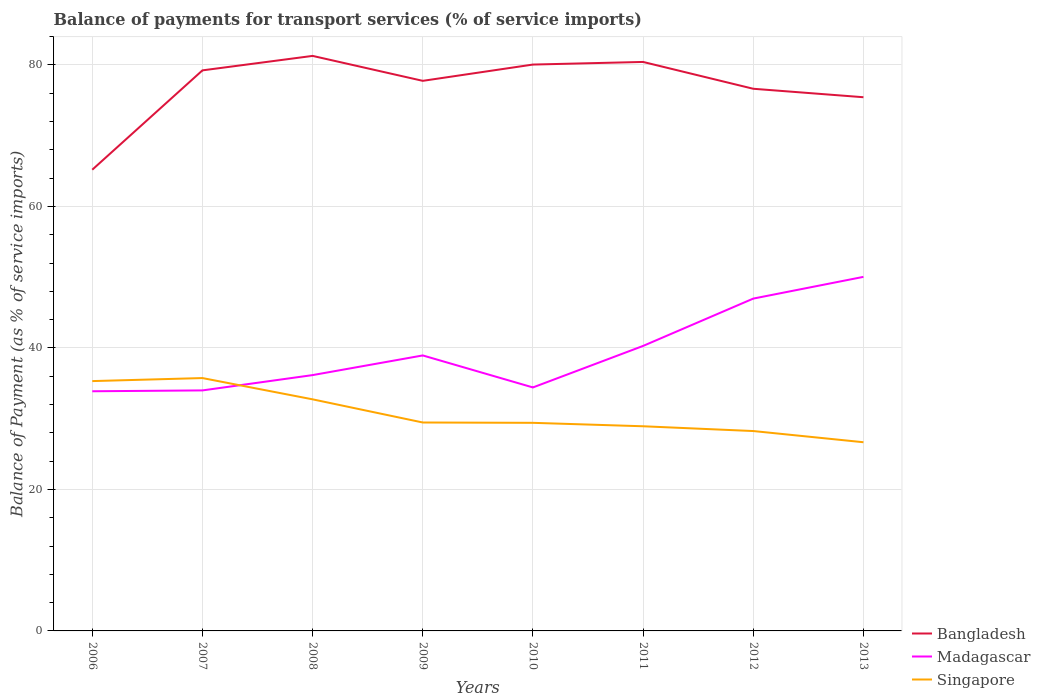How many different coloured lines are there?
Your response must be concise. 3. Across all years, what is the maximum balance of payments for transport services in Madagascar?
Your response must be concise. 33.88. What is the total balance of payments for transport services in Singapore in the graph?
Your answer should be very brief. 3.81. What is the difference between the highest and the second highest balance of payments for transport services in Singapore?
Provide a short and direct response. 9.07. What is the difference between the highest and the lowest balance of payments for transport services in Madagascar?
Your answer should be very brief. 3. How many lines are there?
Keep it short and to the point. 3. What is the difference between two consecutive major ticks on the Y-axis?
Provide a short and direct response. 20. How many legend labels are there?
Ensure brevity in your answer.  3. What is the title of the graph?
Provide a short and direct response. Balance of payments for transport services (% of service imports). Does "Slovak Republic" appear as one of the legend labels in the graph?
Offer a terse response. No. What is the label or title of the Y-axis?
Your answer should be very brief. Balance of Payment (as % of service imports). What is the Balance of Payment (as % of service imports) in Bangladesh in 2006?
Make the answer very short. 65.2. What is the Balance of Payment (as % of service imports) in Madagascar in 2006?
Your answer should be compact. 33.88. What is the Balance of Payment (as % of service imports) in Singapore in 2006?
Your answer should be very brief. 35.31. What is the Balance of Payment (as % of service imports) in Bangladesh in 2007?
Your response must be concise. 79.24. What is the Balance of Payment (as % of service imports) of Madagascar in 2007?
Your answer should be compact. 34. What is the Balance of Payment (as % of service imports) of Singapore in 2007?
Your response must be concise. 35.74. What is the Balance of Payment (as % of service imports) in Bangladesh in 2008?
Your response must be concise. 81.29. What is the Balance of Payment (as % of service imports) of Madagascar in 2008?
Offer a very short reply. 36.16. What is the Balance of Payment (as % of service imports) in Singapore in 2008?
Offer a terse response. 32.74. What is the Balance of Payment (as % of service imports) in Bangladesh in 2009?
Provide a short and direct response. 77.76. What is the Balance of Payment (as % of service imports) in Madagascar in 2009?
Ensure brevity in your answer.  38.94. What is the Balance of Payment (as % of service imports) of Singapore in 2009?
Ensure brevity in your answer.  29.46. What is the Balance of Payment (as % of service imports) of Bangladesh in 2010?
Provide a short and direct response. 80.06. What is the Balance of Payment (as % of service imports) of Madagascar in 2010?
Your answer should be compact. 34.42. What is the Balance of Payment (as % of service imports) of Singapore in 2010?
Your answer should be compact. 29.42. What is the Balance of Payment (as % of service imports) of Bangladesh in 2011?
Offer a very short reply. 80.43. What is the Balance of Payment (as % of service imports) of Madagascar in 2011?
Your answer should be very brief. 40.29. What is the Balance of Payment (as % of service imports) of Singapore in 2011?
Offer a very short reply. 28.93. What is the Balance of Payment (as % of service imports) in Bangladesh in 2012?
Make the answer very short. 76.64. What is the Balance of Payment (as % of service imports) in Madagascar in 2012?
Provide a succinct answer. 46.98. What is the Balance of Payment (as % of service imports) in Singapore in 2012?
Your answer should be very brief. 28.25. What is the Balance of Payment (as % of service imports) in Bangladesh in 2013?
Offer a terse response. 75.44. What is the Balance of Payment (as % of service imports) of Madagascar in 2013?
Make the answer very short. 50.05. What is the Balance of Payment (as % of service imports) in Singapore in 2013?
Offer a terse response. 26.67. Across all years, what is the maximum Balance of Payment (as % of service imports) of Bangladesh?
Ensure brevity in your answer.  81.29. Across all years, what is the maximum Balance of Payment (as % of service imports) in Madagascar?
Your answer should be very brief. 50.05. Across all years, what is the maximum Balance of Payment (as % of service imports) of Singapore?
Offer a very short reply. 35.74. Across all years, what is the minimum Balance of Payment (as % of service imports) of Bangladesh?
Keep it short and to the point. 65.2. Across all years, what is the minimum Balance of Payment (as % of service imports) of Madagascar?
Make the answer very short. 33.88. Across all years, what is the minimum Balance of Payment (as % of service imports) of Singapore?
Offer a terse response. 26.67. What is the total Balance of Payment (as % of service imports) of Bangladesh in the graph?
Offer a terse response. 616.05. What is the total Balance of Payment (as % of service imports) of Madagascar in the graph?
Your answer should be very brief. 314.71. What is the total Balance of Payment (as % of service imports) of Singapore in the graph?
Ensure brevity in your answer.  246.53. What is the difference between the Balance of Payment (as % of service imports) of Bangladesh in 2006 and that in 2007?
Give a very brief answer. -14.04. What is the difference between the Balance of Payment (as % of service imports) in Madagascar in 2006 and that in 2007?
Make the answer very short. -0.12. What is the difference between the Balance of Payment (as % of service imports) of Singapore in 2006 and that in 2007?
Keep it short and to the point. -0.43. What is the difference between the Balance of Payment (as % of service imports) in Bangladesh in 2006 and that in 2008?
Ensure brevity in your answer.  -16.09. What is the difference between the Balance of Payment (as % of service imports) of Madagascar in 2006 and that in 2008?
Provide a succinct answer. -2.28. What is the difference between the Balance of Payment (as % of service imports) in Singapore in 2006 and that in 2008?
Offer a terse response. 2.58. What is the difference between the Balance of Payment (as % of service imports) of Bangladesh in 2006 and that in 2009?
Ensure brevity in your answer.  -12.56. What is the difference between the Balance of Payment (as % of service imports) of Madagascar in 2006 and that in 2009?
Your answer should be very brief. -5.06. What is the difference between the Balance of Payment (as % of service imports) in Singapore in 2006 and that in 2009?
Your response must be concise. 5.85. What is the difference between the Balance of Payment (as % of service imports) in Bangladesh in 2006 and that in 2010?
Ensure brevity in your answer.  -14.86. What is the difference between the Balance of Payment (as % of service imports) in Madagascar in 2006 and that in 2010?
Ensure brevity in your answer.  -0.54. What is the difference between the Balance of Payment (as % of service imports) in Singapore in 2006 and that in 2010?
Ensure brevity in your answer.  5.9. What is the difference between the Balance of Payment (as % of service imports) in Bangladesh in 2006 and that in 2011?
Your answer should be compact. -15.23. What is the difference between the Balance of Payment (as % of service imports) of Madagascar in 2006 and that in 2011?
Provide a short and direct response. -6.41. What is the difference between the Balance of Payment (as % of service imports) of Singapore in 2006 and that in 2011?
Ensure brevity in your answer.  6.38. What is the difference between the Balance of Payment (as % of service imports) of Bangladesh in 2006 and that in 2012?
Your response must be concise. -11.44. What is the difference between the Balance of Payment (as % of service imports) of Madagascar in 2006 and that in 2012?
Give a very brief answer. -13.1. What is the difference between the Balance of Payment (as % of service imports) in Singapore in 2006 and that in 2012?
Ensure brevity in your answer.  7.06. What is the difference between the Balance of Payment (as % of service imports) of Bangladesh in 2006 and that in 2013?
Offer a very short reply. -10.25. What is the difference between the Balance of Payment (as % of service imports) in Madagascar in 2006 and that in 2013?
Offer a terse response. -16.17. What is the difference between the Balance of Payment (as % of service imports) in Singapore in 2006 and that in 2013?
Provide a succinct answer. 8.64. What is the difference between the Balance of Payment (as % of service imports) of Bangladesh in 2007 and that in 2008?
Give a very brief answer. -2.05. What is the difference between the Balance of Payment (as % of service imports) in Madagascar in 2007 and that in 2008?
Provide a succinct answer. -2.16. What is the difference between the Balance of Payment (as % of service imports) of Singapore in 2007 and that in 2008?
Provide a succinct answer. 3.01. What is the difference between the Balance of Payment (as % of service imports) in Bangladesh in 2007 and that in 2009?
Provide a succinct answer. 1.48. What is the difference between the Balance of Payment (as % of service imports) of Madagascar in 2007 and that in 2009?
Offer a terse response. -4.94. What is the difference between the Balance of Payment (as % of service imports) in Singapore in 2007 and that in 2009?
Provide a succinct answer. 6.28. What is the difference between the Balance of Payment (as % of service imports) of Bangladesh in 2007 and that in 2010?
Give a very brief answer. -0.82. What is the difference between the Balance of Payment (as % of service imports) of Madagascar in 2007 and that in 2010?
Ensure brevity in your answer.  -0.42. What is the difference between the Balance of Payment (as % of service imports) of Singapore in 2007 and that in 2010?
Offer a terse response. 6.33. What is the difference between the Balance of Payment (as % of service imports) of Bangladesh in 2007 and that in 2011?
Ensure brevity in your answer.  -1.19. What is the difference between the Balance of Payment (as % of service imports) in Madagascar in 2007 and that in 2011?
Your answer should be very brief. -6.29. What is the difference between the Balance of Payment (as % of service imports) of Singapore in 2007 and that in 2011?
Your response must be concise. 6.81. What is the difference between the Balance of Payment (as % of service imports) in Bangladesh in 2007 and that in 2012?
Ensure brevity in your answer.  2.6. What is the difference between the Balance of Payment (as % of service imports) in Madagascar in 2007 and that in 2012?
Make the answer very short. -12.98. What is the difference between the Balance of Payment (as % of service imports) of Singapore in 2007 and that in 2012?
Provide a succinct answer. 7.49. What is the difference between the Balance of Payment (as % of service imports) in Bangladesh in 2007 and that in 2013?
Ensure brevity in your answer.  3.8. What is the difference between the Balance of Payment (as % of service imports) in Madagascar in 2007 and that in 2013?
Ensure brevity in your answer.  -16.05. What is the difference between the Balance of Payment (as % of service imports) of Singapore in 2007 and that in 2013?
Your response must be concise. 9.07. What is the difference between the Balance of Payment (as % of service imports) in Bangladesh in 2008 and that in 2009?
Your answer should be very brief. 3.53. What is the difference between the Balance of Payment (as % of service imports) of Madagascar in 2008 and that in 2009?
Offer a terse response. -2.78. What is the difference between the Balance of Payment (as % of service imports) in Singapore in 2008 and that in 2009?
Give a very brief answer. 3.27. What is the difference between the Balance of Payment (as % of service imports) of Bangladesh in 2008 and that in 2010?
Offer a terse response. 1.22. What is the difference between the Balance of Payment (as % of service imports) in Madagascar in 2008 and that in 2010?
Give a very brief answer. 1.74. What is the difference between the Balance of Payment (as % of service imports) in Singapore in 2008 and that in 2010?
Keep it short and to the point. 3.32. What is the difference between the Balance of Payment (as % of service imports) in Bangladesh in 2008 and that in 2011?
Provide a succinct answer. 0.86. What is the difference between the Balance of Payment (as % of service imports) in Madagascar in 2008 and that in 2011?
Make the answer very short. -4.12. What is the difference between the Balance of Payment (as % of service imports) of Singapore in 2008 and that in 2011?
Your answer should be very brief. 3.81. What is the difference between the Balance of Payment (as % of service imports) in Bangladesh in 2008 and that in 2012?
Make the answer very short. 4.65. What is the difference between the Balance of Payment (as % of service imports) of Madagascar in 2008 and that in 2012?
Offer a terse response. -10.81. What is the difference between the Balance of Payment (as % of service imports) in Singapore in 2008 and that in 2012?
Provide a short and direct response. 4.48. What is the difference between the Balance of Payment (as % of service imports) of Bangladesh in 2008 and that in 2013?
Ensure brevity in your answer.  5.84. What is the difference between the Balance of Payment (as % of service imports) of Madagascar in 2008 and that in 2013?
Provide a succinct answer. -13.89. What is the difference between the Balance of Payment (as % of service imports) of Singapore in 2008 and that in 2013?
Provide a short and direct response. 6.06. What is the difference between the Balance of Payment (as % of service imports) in Bangladesh in 2009 and that in 2010?
Keep it short and to the point. -2.3. What is the difference between the Balance of Payment (as % of service imports) of Madagascar in 2009 and that in 2010?
Offer a terse response. 4.52. What is the difference between the Balance of Payment (as % of service imports) of Singapore in 2009 and that in 2010?
Offer a terse response. 0.05. What is the difference between the Balance of Payment (as % of service imports) of Bangladesh in 2009 and that in 2011?
Provide a succinct answer. -2.67. What is the difference between the Balance of Payment (as % of service imports) in Madagascar in 2009 and that in 2011?
Ensure brevity in your answer.  -1.35. What is the difference between the Balance of Payment (as % of service imports) of Singapore in 2009 and that in 2011?
Make the answer very short. 0.53. What is the difference between the Balance of Payment (as % of service imports) of Bangladesh in 2009 and that in 2012?
Your response must be concise. 1.12. What is the difference between the Balance of Payment (as % of service imports) in Madagascar in 2009 and that in 2012?
Give a very brief answer. -8.03. What is the difference between the Balance of Payment (as % of service imports) of Singapore in 2009 and that in 2012?
Make the answer very short. 1.21. What is the difference between the Balance of Payment (as % of service imports) of Bangladesh in 2009 and that in 2013?
Offer a terse response. 2.32. What is the difference between the Balance of Payment (as % of service imports) of Madagascar in 2009 and that in 2013?
Make the answer very short. -11.11. What is the difference between the Balance of Payment (as % of service imports) of Singapore in 2009 and that in 2013?
Your response must be concise. 2.79. What is the difference between the Balance of Payment (as % of service imports) in Bangladesh in 2010 and that in 2011?
Provide a succinct answer. -0.37. What is the difference between the Balance of Payment (as % of service imports) of Madagascar in 2010 and that in 2011?
Provide a short and direct response. -5.87. What is the difference between the Balance of Payment (as % of service imports) of Singapore in 2010 and that in 2011?
Provide a succinct answer. 0.49. What is the difference between the Balance of Payment (as % of service imports) in Bangladesh in 2010 and that in 2012?
Offer a terse response. 3.42. What is the difference between the Balance of Payment (as % of service imports) of Madagascar in 2010 and that in 2012?
Offer a very short reply. -12.56. What is the difference between the Balance of Payment (as % of service imports) of Singapore in 2010 and that in 2012?
Ensure brevity in your answer.  1.16. What is the difference between the Balance of Payment (as % of service imports) in Bangladesh in 2010 and that in 2013?
Give a very brief answer. 4.62. What is the difference between the Balance of Payment (as % of service imports) in Madagascar in 2010 and that in 2013?
Your answer should be compact. -15.63. What is the difference between the Balance of Payment (as % of service imports) of Singapore in 2010 and that in 2013?
Give a very brief answer. 2.74. What is the difference between the Balance of Payment (as % of service imports) in Bangladesh in 2011 and that in 2012?
Provide a short and direct response. 3.79. What is the difference between the Balance of Payment (as % of service imports) of Madagascar in 2011 and that in 2012?
Offer a very short reply. -6.69. What is the difference between the Balance of Payment (as % of service imports) in Singapore in 2011 and that in 2012?
Your answer should be very brief. 0.67. What is the difference between the Balance of Payment (as % of service imports) in Bangladesh in 2011 and that in 2013?
Offer a very short reply. 4.99. What is the difference between the Balance of Payment (as % of service imports) in Madagascar in 2011 and that in 2013?
Your answer should be compact. -9.76. What is the difference between the Balance of Payment (as % of service imports) in Singapore in 2011 and that in 2013?
Provide a succinct answer. 2.26. What is the difference between the Balance of Payment (as % of service imports) of Bangladesh in 2012 and that in 2013?
Keep it short and to the point. 1.2. What is the difference between the Balance of Payment (as % of service imports) in Madagascar in 2012 and that in 2013?
Ensure brevity in your answer.  -3.07. What is the difference between the Balance of Payment (as % of service imports) of Singapore in 2012 and that in 2013?
Your response must be concise. 1.58. What is the difference between the Balance of Payment (as % of service imports) in Bangladesh in 2006 and the Balance of Payment (as % of service imports) in Madagascar in 2007?
Offer a very short reply. 31.2. What is the difference between the Balance of Payment (as % of service imports) of Bangladesh in 2006 and the Balance of Payment (as % of service imports) of Singapore in 2007?
Your response must be concise. 29.45. What is the difference between the Balance of Payment (as % of service imports) of Madagascar in 2006 and the Balance of Payment (as % of service imports) of Singapore in 2007?
Your response must be concise. -1.87. What is the difference between the Balance of Payment (as % of service imports) in Bangladesh in 2006 and the Balance of Payment (as % of service imports) in Madagascar in 2008?
Your answer should be very brief. 29.03. What is the difference between the Balance of Payment (as % of service imports) in Bangladesh in 2006 and the Balance of Payment (as % of service imports) in Singapore in 2008?
Provide a short and direct response. 32.46. What is the difference between the Balance of Payment (as % of service imports) of Madagascar in 2006 and the Balance of Payment (as % of service imports) of Singapore in 2008?
Offer a terse response. 1.14. What is the difference between the Balance of Payment (as % of service imports) of Bangladesh in 2006 and the Balance of Payment (as % of service imports) of Madagascar in 2009?
Your answer should be compact. 26.25. What is the difference between the Balance of Payment (as % of service imports) in Bangladesh in 2006 and the Balance of Payment (as % of service imports) in Singapore in 2009?
Offer a terse response. 35.73. What is the difference between the Balance of Payment (as % of service imports) of Madagascar in 2006 and the Balance of Payment (as % of service imports) of Singapore in 2009?
Your answer should be very brief. 4.42. What is the difference between the Balance of Payment (as % of service imports) in Bangladesh in 2006 and the Balance of Payment (as % of service imports) in Madagascar in 2010?
Offer a very short reply. 30.78. What is the difference between the Balance of Payment (as % of service imports) in Bangladesh in 2006 and the Balance of Payment (as % of service imports) in Singapore in 2010?
Offer a terse response. 35.78. What is the difference between the Balance of Payment (as % of service imports) of Madagascar in 2006 and the Balance of Payment (as % of service imports) of Singapore in 2010?
Provide a succinct answer. 4.46. What is the difference between the Balance of Payment (as % of service imports) in Bangladesh in 2006 and the Balance of Payment (as % of service imports) in Madagascar in 2011?
Your answer should be very brief. 24.91. What is the difference between the Balance of Payment (as % of service imports) of Bangladesh in 2006 and the Balance of Payment (as % of service imports) of Singapore in 2011?
Make the answer very short. 36.27. What is the difference between the Balance of Payment (as % of service imports) in Madagascar in 2006 and the Balance of Payment (as % of service imports) in Singapore in 2011?
Ensure brevity in your answer.  4.95. What is the difference between the Balance of Payment (as % of service imports) of Bangladesh in 2006 and the Balance of Payment (as % of service imports) of Madagascar in 2012?
Your answer should be compact. 18.22. What is the difference between the Balance of Payment (as % of service imports) in Bangladesh in 2006 and the Balance of Payment (as % of service imports) in Singapore in 2012?
Your answer should be compact. 36.94. What is the difference between the Balance of Payment (as % of service imports) of Madagascar in 2006 and the Balance of Payment (as % of service imports) of Singapore in 2012?
Ensure brevity in your answer.  5.62. What is the difference between the Balance of Payment (as % of service imports) of Bangladesh in 2006 and the Balance of Payment (as % of service imports) of Madagascar in 2013?
Your response must be concise. 15.15. What is the difference between the Balance of Payment (as % of service imports) of Bangladesh in 2006 and the Balance of Payment (as % of service imports) of Singapore in 2013?
Give a very brief answer. 38.52. What is the difference between the Balance of Payment (as % of service imports) in Madagascar in 2006 and the Balance of Payment (as % of service imports) in Singapore in 2013?
Ensure brevity in your answer.  7.21. What is the difference between the Balance of Payment (as % of service imports) in Bangladesh in 2007 and the Balance of Payment (as % of service imports) in Madagascar in 2008?
Offer a very short reply. 43.08. What is the difference between the Balance of Payment (as % of service imports) in Bangladesh in 2007 and the Balance of Payment (as % of service imports) in Singapore in 2008?
Provide a short and direct response. 46.5. What is the difference between the Balance of Payment (as % of service imports) of Madagascar in 2007 and the Balance of Payment (as % of service imports) of Singapore in 2008?
Ensure brevity in your answer.  1.26. What is the difference between the Balance of Payment (as % of service imports) of Bangladesh in 2007 and the Balance of Payment (as % of service imports) of Madagascar in 2009?
Offer a terse response. 40.3. What is the difference between the Balance of Payment (as % of service imports) of Bangladesh in 2007 and the Balance of Payment (as % of service imports) of Singapore in 2009?
Keep it short and to the point. 49.78. What is the difference between the Balance of Payment (as % of service imports) in Madagascar in 2007 and the Balance of Payment (as % of service imports) in Singapore in 2009?
Ensure brevity in your answer.  4.54. What is the difference between the Balance of Payment (as % of service imports) in Bangladesh in 2007 and the Balance of Payment (as % of service imports) in Madagascar in 2010?
Your answer should be compact. 44.82. What is the difference between the Balance of Payment (as % of service imports) in Bangladesh in 2007 and the Balance of Payment (as % of service imports) in Singapore in 2010?
Make the answer very short. 49.82. What is the difference between the Balance of Payment (as % of service imports) of Madagascar in 2007 and the Balance of Payment (as % of service imports) of Singapore in 2010?
Your answer should be very brief. 4.58. What is the difference between the Balance of Payment (as % of service imports) of Bangladesh in 2007 and the Balance of Payment (as % of service imports) of Madagascar in 2011?
Give a very brief answer. 38.95. What is the difference between the Balance of Payment (as % of service imports) in Bangladesh in 2007 and the Balance of Payment (as % of service imports) in Singapore in 2011?
Make the answer very short. 50.31. What is the difference between the Balance of Payment (as % of service imports) of Madagascar in 2007 and the Balance of Payment (as % of service imports) of Singapore in 2011?
Your answer should be compact. 5.07. What is the difference between the Balance of Payment (as % of service imports) of Bangladesh in 2007 and the Balance of Payment (as % of service imports) of Madagascar in 2012?
Keep it short and to the point. 32.26. What is the difference between the Balance of Payment (as % of service imports) of Bangladesh in 2007 and the Balance of Payment (as % of service imports) of Singapore in 2012?
Your answer should be compact. 50.98. What is the difference between the Balance of Payment (as % of service imports) in Madagascar in 2007 and the Balance of Payment (as % of service imports) in Singapore in 2012?
Your answer should be compact. 5.74. What is the difference between the Balance of Payment (as % of service imports) of Bangladesh in 2007 and the Balance of Payment (as % of service imports) of Madagascar in 2013?
Keep it short and to the point. 29.19. What is the difference between the Balance of Payment (as % of service imports) of Bangladesh in 2007 and the Balance of Payment (as % of service imports) of Singapore in 2013?
Your answer should be very brief. 52.57. What is the difference between the Balance of Payment (as % of service imports) in Madagascar in 2007 and the Balance of Payment (as % of service imports) in Singapore in 2013?
Your answer should be very brief. 7.33. What is the difference between the Balance of Payment (as % of service imports) in Bangladesh in 2008 and the Balance of Payment (as % of service imports) in Madagascar in 2009?
Ensure brevity in your answer.  42.34. What is the difference between the Balance of Payment (as % of service imports) in Bangladesh in 2008 and the Balance of Payment (as % of service imports) in Singapore in 2009?
Offer a very short reply. 51.82. What is the difference between the Balance of Payment (as % of service imports) of Madagascar in 2008 and the Balance of Payment (as % of service imports) of Singapore in 2009?
Provide a short and direct response. 6.7. What is the difference between the Balance of Payment (as % of service imports) of Bangladesh in 2008 and the Balance of Payment (as % of service imports) of Madagascar in 2010?
Provide a short and direct response. 46.87. What is the difference between the Balance of Payment (as % of service imports) in Bangladesh in 2008 and the Balance of Payment (as % of service imports) in Singapore in 2010?
Offer a terse response. 51.87. What is the difference between the Balance of Payment (as % of service imports) in Madagascar in 2008 and the Balance of Payment (as % of service imports) in Singapore in 2010?
Provide a succinct answer. 6.75. What is the difference between the Balance of Payment (as % of service imports) in Bangladesh in 2008 and the Balance of Payment (as % of service imports) in Madagascar in 2011?
Keep it short and to the point. 41. What is the difference between the Balance of Payment (as % of service imports) of Bangladesh in 2008 and the Balance of Payment (as % of service imports) of Singapore in 2011?
Give a very brief answer. 52.36. What is the difference between the Balance of Payment (as % of service imports) in Madagascar in 2008 and the Balance of Payment (as % of service imports) in Singapore in 2011?
Offer a very short reply. 7.23. What is the difference between the Balance of Payment (as % of service imports) of Bangladesh in 2008 and the Balance of Payment (as % of service imports) of Madagascar in 2012?
Make the answer very short. 34.31. What is the difference between the Balance of Payment (as % of service imports) of Bangladesh in 2008 and the Balance of Payment (as % of service imports) of Singapore in 2012?
Your answer should be compact. 53.03. What is the difference between the Balance of Payment (as % of service imports) of Madagascar in 2008 and the Balance of Payment (as % of service imports) of Singapore in 2012?
Keep it short and to the point. 7.91. What is the difference between the Balance of Payment (as % of service imports) of Bangladesh in 2008 and the Balance of Payment (as % of service imports) of Madagascar in 2013?
Your response must be concise. 31.24. What is the difference between the Balance of Payment (as % of service imports) of Bangladesh in 2008 and the Balance of Payment (as % of service imports) of Singapore in 2013?
Your response must be concise. 54.61. What is the difference between the Balance of Payment (as % of service imports) of Madagascar in 2008 and the Balance of Payment (as % of service imports) of Singapore in 2013?
Your response must be concise. 9.49. What is the difference between the Balance of Payment (as % of service imports) in Bangladesh in 2009 and the Balance of Payment (as % of service imports) in Madagascar in 2010?
Offer a very short reply. 43.34. What is the difference between the Balance of Payment (as % of service imports) of Bangladesh in 2009 and the Balance of Payment (as % of service imports) of Singapore in 2010?
Ensure brevity in your answer.  48.34. What is the difference between the Balance of Payment (as % of service imports) in Madagascar in 2009 and the Balance of Payment (as % of service imports) in Singapore in 2010?
Give a very brief answer. 9.53. What is the difference between the Balance of Payment (as % of service imports) in Bangladesh in 2009 and the Balance of Payment (as % of service imports) in Madagascar in 2011?
Offer a very short reply. 37.47. What is the difference between the Balance of Payment (as % of service imports) of Bangladesh in 2009 and the Balance of Payment (as % of service imports) of Singapore in 2011?
Give a very brief answer. 48.83. What is the difference between the Balance of Payment (as % of service imports) of Madagascar in 2009 and the Balance of Payment (as % of service imports) of Singapore in 2011?
Provide a succinct answer. 10.01. What is the difference between the Balance of Payment (as % of service imports) in Bangladesh in 2009 and the Balance of Payment (as % of service imports) in Madagascar in 2012?
Make the answer very short. 30.78. What is the difference between the Balance of Payment (as % of service imports) of Bangladesh in 2009 and the Balance of Payment (as % of service imports) of Singapore in 2012?
Ensure brevity in your answer.  49.5. What is the difference between the Balance of Payment (as % of service imports) of Madagascar in 2009 and the Balance of Payment (as % of service imports) of Singapore in 2012?
Provide a short and direct response. 10.69. What is the difference between the Balance of Payment (as % of service imports) of Bangladesh in 2009 and the Balance of Payment (as % of service imports) of Madagascar in 2013?
Provide a succinct answer. 27.71. What is the difference between the Balance of Payment (as % of service imports) of Bangladesh in 2009 and the Balance of Payment (as % of service imports) of Singapore in 2013?
Your answer should be very brief. 51.09. What is the difference between the Balance of Payment (as % of service imports) in Madagascar in 2009 and the Balance of Payment (as % of service imports) in Singapore in 2013?
Offer a very short reply. 12.27. What is the difference between the Balance of Payment (as % of service imports) in Bangladesh in 2010 and the Balance of Payment (as % of service imports) in Madagascar in 2011?
Keep it short and to the point. 39.77. What is the difference between the Balance of Payment (as % of service imports) in Bangladesh in 2010 and the Balance of Payment (as % of service imports) in Singapore in 2011?
Offer a terse response. 51.13. What is the difference between the Balance of Payment (as % of service imports) in Madagascar in 2010 and the Balance of Payment (as % of service imports) in Singapore in 2011?
Make the answer very short. 5.49. What is the difference between the Balance of Payment (as % of service imports) of Bangladesh in 2010 and the Balance of Payment (as % of service imports) of Madagascar in 2012?
Make the answer very short. 33.08. What is the difference between the Balance of Payment (as % of service imports) in Bangladesh in 2010 and the Balance of Payment (as % of service imports) in Singapore in 2012?
Your answer should be compact. 51.81. What is the difference between the Balance of Payment (as % of service imports) in Madagascar in 2010 and the Balance of Payment (as % of service imports) in Singapore in 2012?
Your response must be concise. 6.16. What is the difference between the Balance of Payment (as % of service imports) of Bangladesh in 2010 and the Balance of Payment (as % of service imports) of Madagascar in 2013?
Give a very brief answer. 30.01. What is the difference between the Balance of Payment (as % of service imports) of Bangladesh in 2010 and the Balance of Payment (as % of service imports) of Singapore in 2013?
Offer a very short reply. 53.39. What is the difference between the Balance of Payment (as % of service imports) in Madagascar in 2010 and the Balance of Payment (as % of service imports) in Singapore in 2013?
Provide a succinct answer. 7.75. What is the difference between the Balance of Payment (as % of service imports) of Bangladesh in 2011 and the Balance of Payment (as % of service imports) of Madagascar in 2012?
Keep it short and to the point. 33.45. What is the difference between the Balance of Payment (as % of service imports) in Bangladesh in 2011 and the Balance of Payment (as % of service imports) in Singapore in 2012?
Your answer should be compact. 52.17. What is the difference between the Balance of Payment (as % of service imports) of Madagascar in 2011 and the Balance of Payment (as % of service imports) of Singapore in 2012?
Keep it short and to the point. 12.03. What is the difference between the Balance of Payment (as % of service imports) in Bangladesh in 2011 and the Balance of Payment (as % of service imports) in Madagascar in 2013?
Offer a terse response. 30.38. What is the difference between the Balance of Payment (as % of service imports) in Bangladesh in 2011 and the Balance of Payment (as % of service imports) in Singapore in 2013?
Your answer should be compact. 53.76. What is the difference between the Balance of Payment (as % of service imports) in Madagascar in 2011 and the Balance of Payment (as % of service imports) in Singapore in 2013?
Offer a very short reply. 13.61. What is the difference between the Balance of Payment (as % of service imports) of Bangladesh in 2012 and the Balance of Payment (as % of service imports) of Madagascar in 2013?
Keep it short and to the point. 26.59. What is the difference between the Balance of Payment (as % of service imports) of Bangladesh in 2012 and the Balance of Payment (as % of service imports) of Singapore in 2013?
Ensure brevity in your answer.  49.97. What is the difference between the Balance of Payment (as % of service imports) of Madagascar in 2012 and the Balance of Payment (as % of service imports) of Singapore in 2013?
Provide a succinct answer. 20.3. What is the average Balance of Payment (as % of service imports) of Bangladesh per year?
Give a very brief answer. 77.01. What is the average Balance of Payment (as % of service imports) of Madagascar per year?
Provide a short and direct response. 39.34. What is the average Balance of Payment (as % of service imports) of Singapore per year?
Ensure brevity in your answer.  30.82. In the year 2006, what is the difference between the Balance of Payment (as % of service imports) in Bangladesh and Balance of Payment (as % of service imports) in Madagascar?
Your answer should be very brief. 31.32. In the year 2006, what is the difference between the Balance of Payment (as % of service imports) in Bangladesh and Balance of Payment (as % of service imports) in Singapore?
Your answer should be very brief. 29.88. In the year 2006, what is the difference between the Balance of Payment (as % of service imports) of Madagascar and Balance of Payment (as % of service imports) of Singapore?
Make the answer very short. -1.44. In the year 2007, what is the difference between the Balance of Payment (as % of service imports) of Bangladesh and Balance of Payment (as % of service imports) of Madagascar?
Give a very brief answer. 45.24. In the year 2007, what is the difference between the Balance of Payment (as % of service imports) in Bangladesh and Balance of Payment (as % of service imports) in Singapore?
Provide a short and direct response. 43.5. In the year 2007, what is the difference between the Balance of Payment (as % of service imports) of Madagascar and Balance of Payment (as % of service imports) of Singapore?
Provide a short and direct response. -1.74. In the year 2008, what is the difference between the Balance of Payment (as % of service imports) of Bangladesh and Balance of Payment (as % of service imports) of Madagascar?
Ensure brevity in your answer.  45.12. In the year 2008, what is the difference between the Balance of Payment (as % of service imports) in Bangladesh and Balance of Payment (as % of service imports) in Singapore?
Ensure brevity in your answer.  48.55. In the year 2008, what is the difference between the Balance of Payment (as % of service imports) in Madagascar and Balance of Payment (as % of service imports) in Singapore?
Provide a succinct answer. 3.43. In the year 2009, what is the difference between the Balance of Payment (as % of service imports) of Bangladesh and Balance of Payment (as % of service imports) of Madagascar?
Your answer should be compact. 38.82. In the year 2009, what is the difference between the Balance of Payment (as % of service imports) in Bangladesh and Balance of Payment (as % of service imports) in Singapore?
Your answer should be compact. 48.3. In the year 2009, what is the difference between the Balance of Payment (as % of service imports) in Madagascar and Balance of Payment (as % of service imports) in Singapore?
Offer a terse response. 9.48. In the year 2010, what is the difference between the Balance of Payment (as % of service imports) in Bangladesh and Balance of Payment (as % of service imports) in Madagascar?
Provide a short and direct response. 45.64. In the year 2010, what is the difference between the Balance of Payment (as % of service imports) of Bangladesh and Balance of Payment (as % of service imports) of Singapore?
Your answer should be compact. 50.64. In the year 2010, what is the difference between the Balance of Payment (as % of service imports) of Madagascar and Balance of Payment (as % of service imports) of Singapore?
Offer a very short reply. 5. In the year 2011, what is the difference between the Balance of Payment (as % of service imports) in Bangladesh and Balance of Payment (as % of service imports) in Madagascar?
Offer a very short reply. 40.14. In the year 2011, what is the difference between the Balance of Payment (as % of service imports) of Bangladesh and Balance of Payment (as % of service imports) of Singapore?
Provide a short and direct response. 51.5. In the year 2011, what is the difference between the Balance of Payment (as % of service imports) of Madagascar and Balance of Payment (as % of service imports) of Singapore?
Offer a very short reply. 11.36. In the year 2012, what is the difference between the Balance of Payment (as % of service imports) of Bangladesh and Balance of Payment (as % of service imports) of Madagascar?
Offer a very short reply. 29.66. In the year 2012, what is the difference between the Balance of Payment (as % of service imports) in Bangladesh and Balance of Payment (as % of service imports) in Singapore?
Keep it short and to the point. 48.38. In the year 2012, what is the difference between the Balance of Payment (as % of service imports) in Madagascar and Balance of Payment (as % of service imports) in Singapore?
Your answer should be very brief. 18.72. In the year 2013, what is the difference between the Balance of Payment (as % of service imports) of Bangladesh and Balance of Payment (as % of service imports) of Madagascar?
Keep it short and to the point. 25.39. In the year 2013, what is the difference between the Balance of Payment (as % of service imports) in Bangladesh and Balance of Payment (as % of service imports) in Singapore?
Provide a short and direct response. 48.77. In the year 2013, what is the difference between the Balance of Payment (as % of service imports) in Madagascar and Balance of Payment (as % of service imports) in Singapore?
Your response must be concise. 23.38. What is the ratio of the Balance of Payment (as % of service imports) of Bangladesh in 2006 to that in 2007?
Make the answer very short. 0.82. What is the ratio of the Balance of Payment (as % of service imports) of Bangladesh in 2006 to that in 2008?
Your answer should be very brief. 0.8. What is the ratio of the Balance of Payment (as % of service imports) of Madagascar in 2006 to that in 2008?
Provide a succinct answer. 0.94. What is the ratio of the Balance of Payment (as % of service imports) in Singapore in 2006 to that in 2008?
Give a very brief answer. 1.08. What is the ratio of the Balance of Payment (as % of service imports) of Bangladesh in 2006 to that in 2009?
Provide a short and direct response. 0.84. What is the ratio of the Balance of Payment (as % of service imports) of Madagascar in 2006 to that in 2009?
Provide a short and direct response. 0.87. What is the ratio of the Balance of Payment (as % of service imports) of Singapore in 2006 to that in 2009?
Provide a short and direct response. 1.2. What is the ratio of the Balance of Payment (as % of service imports) of Bangladesh in 2006 to that in 2010?
Provide a short and direct response. 0.81. What is the ratio of the Balance of Payment (as % of service imports) of Madagascar in 2006 to that in 2010?
Offer a terse response. 0.98. What is the ratio of the Balance of Payment (as % of service imports) of Singapore in 2006 to that in 2010?
Ensure brevity in your answer.  1.2. What is the ratio of the Balance of Payment (as % of service imports) in Bangladesh in 2006 to that in 2011?
Provide a short and direct response. 0.81. What is the ratio of the Balance of Payment (as % of service imports) in Madagascar in 2006 to that in 2011?
Your response must be concise. 0.84. What is the ratio of the Balance of Payment (as % of service imports) of Singapore in 2006 to that in 2011?
Make the answer very short. 1.22. What is the ratio of the Balance of Payment (as % of service imports) of Bangladesh in 2006 to that in 2012?
Your answer should be very brief. 0.85. What is the ratio of the Balance of Payment (as % of service imports) in Madagascar in 2006 to that in 2012?
Offer a very short reply. 0.72. What is the ratio of the Balance of Payment (as % of service imports) of Singapore in 2006 to that in 2012?
Your answer should be compact. 1.25. What is the ratio of the Balance of Payment (as % of service imports) in Bangladesh in 2006 to that in 2013?
Keep it short and to the point. 0.86. What is the ratio of the Balance of Payment (as % of service imports) of Madagascar in 2006 to that in 2013?
Make the answer very short. 0.68. What is the ratio of the Balance of Payment (as % of service imports) of Singapore in 2006 to that in 2013?
Offer a very short reply. 1.32. What is the ratio of the Balance of Payment (as % of service imports) of Bangladesh in 2007 to that in 2008?
Ensure brevity in your answer.  0.97. What is the ratio of the Balance of Payment (as % of service imports) in Madagascar in 2007 to that in 2008?
Give a very brief answer. 0.94. What is the ratio of the Balance of Payment (as % of service imports) in Singapore in 2007 to that in 2008?
Offer a terse response. 1.09. What is the ratio of the Balance of Payment (as % of service imports) of Bangladesh in 2007 to that in 2009?
Give a very brief answer. 1.02. What is the ratio of the Balance of Payment (as % of service imports) of Madagascar in 2007 to that in 2009?
Keep it short and to the point. 0.87. What is the ratio of the Balance of Payment (as % of service imports) in Singapore in 2007 to that in 2009?
Your answer should be very brief. 1.21. What is the ratio of the Balance of Payment (as % of service imports) in Singapore in 2007 to that in 2010?
Your answer should be very brief. 1.22. What is the ratio of the Balance of Payment (as % of service imports) in Bangladesh in 2007 to that in 2011?
Keep it short and to the point. 0.99. What is the ratio of the Balance of Payment (as % of service imports) in Madagascar in 2007 to that in 2011?
Offer a terse response. 0.84. What is the ratio of the Balance of Payment (as % of service imports) of Singapore in 2007 to that in 2011?
Give a very brief answer. 1.24. What is the ratio of the Balance of Payment (as % of service imports) of Bangladesh in 2007 to that in 2012?
Offer a very short reply. 1.03. What is the ratio of the Balance of Payment (as % of service imports) in Madagascar in 2007 to that in 2012?
Your answer should be very brief. 0.72. What is the ratio of the Balance of Payment (as % of service imports) of Singapore in 2007 to that in 2012?
Make the answer very short. 1.26. What is the ratio of the Balance of Payment (as % of service imports) of Bangladesh in 2007 to that in 2013?
Your response must be concise. 1.05. What is the ratio of the Balance of Payment (as % of service imports) of Madagascar in 2007 to that in 2013?
Ensure brevity in your answer.  0.68. What is the ratio of the Balance of Payment (as % of service imports) of Singapore in 2007 to that in 2013?
Your answer should be very brief. 1.34. What is the ratio of the Balance of Payment (as % of service imports) in Bangladesh in 2008 to that in 2009?
Give a very brief answer. 1.05. What is the ratio of the Balance of Payment (as % of service imports) in Singapore in 2008 to that in 2009?
Your response must be concise. 1.11. What is the ratio of the Balance of Payment (as % of service imports) in Bangladesh in 2008 to that in 2010?
Give a very brief answer. 1.02. What is the ratio of the Balance of Payment (as % of service imports) in Madagascar in 2008 to that in 2010?
Give a very brief answer. 1.05. What is the ratio of the Balance of Payment (as % of service imports) in Singapore in 2008 to that in 2010?
Provide a succinct answer. 1.11. What is the ratio of the Balance of Payment (as % of service imports) of Bangladesh in 2008 to that in 2011?
Offer a terse response. 1.01. What is the ratio of the Balance of Payment (as % of service imports) of Madagascar in 2008 to that in 2011?
Provide a succinct answer. 0.9. What is the ratio of the Balance of Payment (as % of service imports) of Singapore in 2008 to that in 2011?
Make the answer very short. 1.13. What is the ratio of the Balance of Payment (as % of service imports) in Bangladesh in 2008 to that in 2012?
Provide a succinct answer. 1.06. What is the ratio of the Balance of Payment (as % of service imports) of Madagascar in 2008 to that in 2012?
Offer a terse response. 0.77. What is the ratio of the Balance of Payment (as % of service imports) of Singapore in 2008 to that in 2012?
Offer a terse response. 1.16. What is the ratio of the Balance of Payment (as % of service imports) of Bangladesh in 2008 to that in 2013?
Give a very brief answer. 1.08. What is the ratio of the Balance of Payment (as % of service imports) in Madagascar in 2008 to that in 2013?
Keep it short and to the point. 0.72. What is the ratio of the Balance of Payment (as % of service imports) of Singapore in 2008 to that in 2013?
Your response must be concise. 1.23. What is the ratio of the Balance of Payment (as % of service imports) of Bangladesh in 2009 to that in 2010?
Your response must be concise. 0.97. What is the ratio of the Balance of Payment (as % of service imports) of Madagascar in 2009 to that in 2010?
Provide a succinct answer. 1.13. What is the ratio of the Balance of Payment (as % of service imports) in Singapore in 2009 to that in 2010?
Give a very brief answer. 1. What is the ratio of the Balance of Payment (as % of service imports) of Bangladesh in 2009 to that in 2011?
Provide a short and direct response. 0.97. What is the ratio of the Balance of Payment (as % of service imports) in Madagascar in 2009 to that in 2011?
Provide a short and direct response. 0.97. What is the ratio of the Balance of Payment (as % of service imports) in Singapore in 2009 to that in 2011?
Provide a succinct answer. 1.02. What is the ratio of the Balance of Payment (as % of service imports) in Bangladesh in 2009 to that in 2012?
Your response must be concise. 1.01. What is the ratio of the Balance of Payment (as % of service imports) in Madagascar in 2009 to that in 2012?
Ensure brevity in your answer.  0.83. What is the ratio of the Balance of Payment (as % of service imports) of Singapore in 2009 to that in 2012?
Offer a terse response. 1.04. What is the ratio of the Balance of Payment (as % of service imports) of Bangladesh in 2009 to that in 2013?
Your answer should be very brief. 1.03. What is the ratio of the Balance of Payment (as % of service imports) in Madagascar in 2009 to that in 2013?
Ensure brevity in your answer.  0.78. What is the ratio of the Balance of Payment (as % of service imports) of Singapore in 2009 to that in 2013?
Provide a succinct answer. 1.1. What is the ratio of the Balance of Payment (as % of service imports) in Bangladesh in 2010 to that in 2011?
Your answer should be very brief. 1. What is the ratio of the Balance of Payment (as % of service imports) in Madagascar in 2010 to that in 2011?
Your answer should be very brief. 0.85. What is the ratio of the Balance of Payment (as % of service imports) in Singapore in 2010 to that in 2011?
Provide a short and direct response. 1.02. What is the ratio of the Balance of Payment (as % of service imports) in Bangladesh in 2010 to that in 2012?
Ensure brevity in your answer.  1.04. What is the ratio of the Balance of Payment (as % of service imports) in Madagascar in 2010 to that in 2012?
Your answer should be very brief. 0.73. What is the ratio of the Balance of Payment (as % of service imports) in Singapore in 2010 to that in 2012?
Your response must be concise. 1.04. What is the ratio of the Balance of Payment (as % of service imports) of Bangladesh in 2010 to that in 2013?
Your answer should be very brief. 1.06. What is the ratio of the Balance of Payment (as % of service imports) in Madagascar in 2010 to that in 2013?
Give a very brief answer. 0.69. What is the ratio of the Balance of Payment (as % of service imports) of Singapore in 2010 to that in 2013?
Ensure brevity in your answer.  1.1. What is the ratio of the Balance of Payment (as % of service imports) in Bangladesh in 2011 to that in 2012?
Keep it short and to the point. 1.05. What is the ratio of the Balance of Payment (as % of service imports) in Madagascar in 2011 to that in 2012?
Your answer should be compact. 0.86. What is the ratio of the Balance of Payment (as % of service imports) of Singapore in 2011 to that in 2012?
Ensure brevity in your answer.  1.02. What is the ratio of the Balance of Payment (as % of service imports) of Bangladesh in 2011 to that in 2013?
Make the answer very short. 1.07. What is the ratio of the Balance of Payment (as % of service imports) in Madagascar in 2011 to that in 2013?
Make the answer very short. 0.81. What is the ratio of the Balance of Payment (as % of service imports) of Singapore in 2011 to that in 2013?
Your response must be concise. 1.08. What is the ratio of the Balance of Payment (as % of service imports) of Bangladesh in 2012 to that in 2013?
Keep it short and to the point. 1.02. What is the ratio of the Balance of Payment (as % of service imports) of Madagascar in 2012 to that in 2013?
Give a very brief answer. 0.94. What is the ratio of the Balance of Payment (as % of service imports) in Singapore in 2012 to that in 2013?
Give a very brief answer. 1.06. What is the difference between the highest and the second highest Balance of Payment (as % of service imports) of Bangladesh?
Your response must be concise. 0.86. What is the difference between the highest and the second highest Balance of Payment (as % of service imports) in Madagascar?
Keep it short and to the point. 3.07. What is the difference between the highest and the second highest Balance of Payment (as % of service imports) in Singapore?
Your response must be concise. 0.43. What is the difference between the highest and the lowest Balance of Payment (as % of service imports) in Bangladesh?
Provide a short and direct response. 16.09. What is the difference between the highest and the lowest Balance of Payment (as % of service imports) in Madagascar?
Your answer should be compact. 16.17. What is the difference between the highest and the lowest Balance of Payment (as % of service imports) in Singapore?
Ensure brevity in your answer.  9.07. 